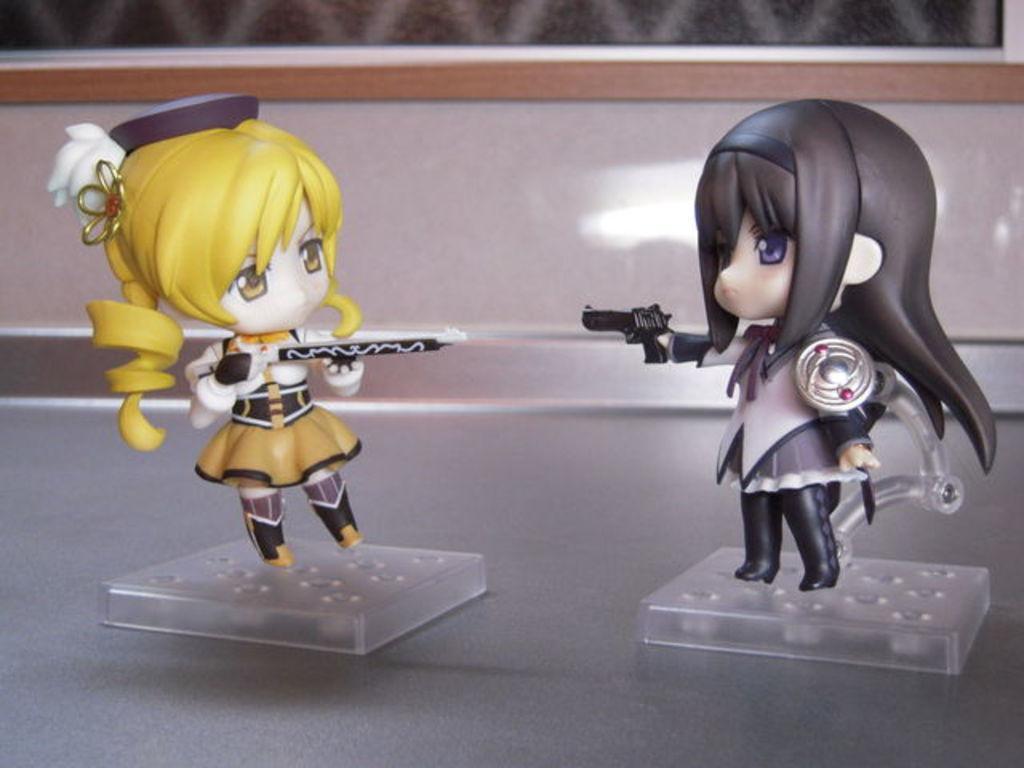In one or two sentences, can you explain what this image depicts? In this picture there are two cartoon doll toys standing in front and placed on the tabletop. Behind there is a brown color wooden wall. 